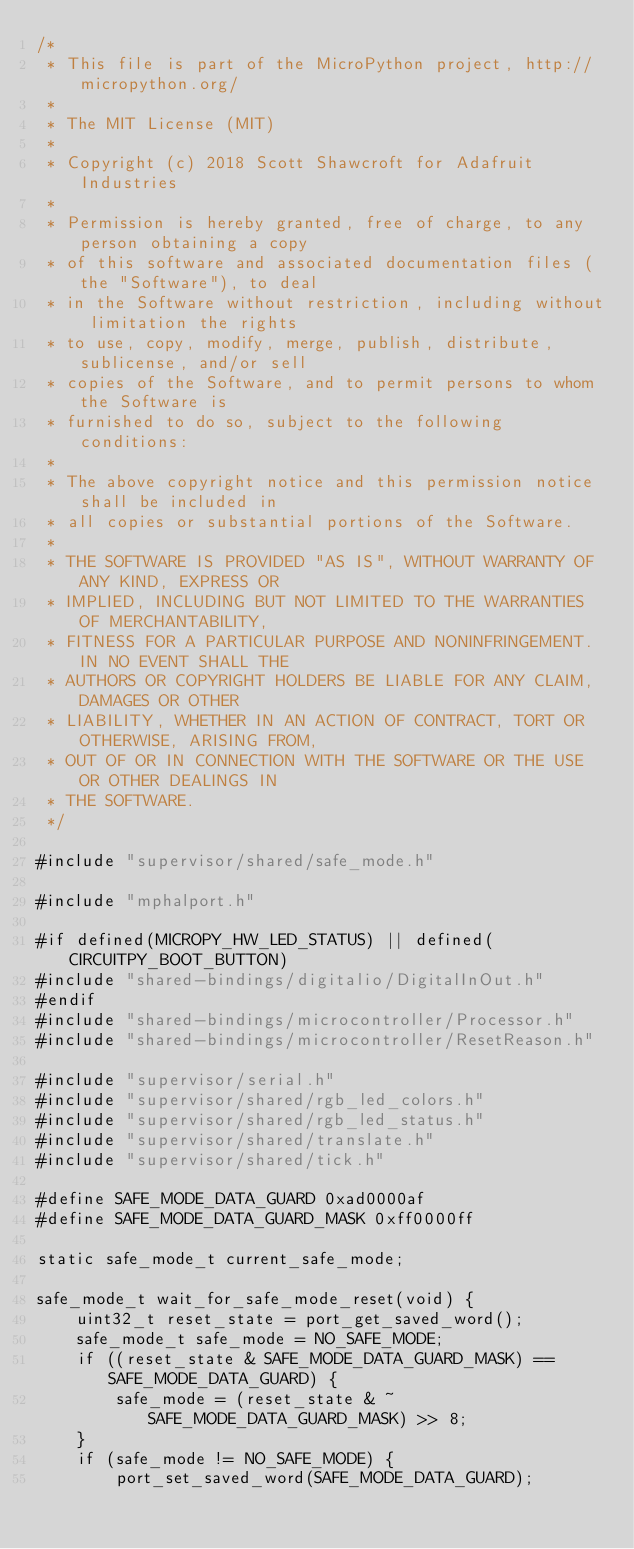<code> <loc_0><loc_0><loc_500><loc_500><_C_>/*
 * This file is part of the MicroPython project, http://micropython.org/
 *
 * The MIT License (MIT)
 *
 * Copyright (c) 2018 Scott Shawcroft for Adafruit Industries
 *
 * Permission is hereby granted, free of charge, to any person obtaining a copy
 * of this software and associated documentation files (the "Software"), to deal
 * in the Software without restriction, including without limitation the rights
 * to use, copy, modify, merge, publish, distribute, sublicense, and/or sell
 * copies of the Software, and to permit persons to whom the Software is
 * furnished to do so, subject to the following conditions:
 *
 * The above copyright notice and this permission notice shall be included in
 * all copies or substantial portions of the Software.
 *
 * THE SOFTWARE IS PROVIDED "AS IS", WITHOUT WARRANTY OF ANY KIND, EXPRESS OR
 * IMPLIED, INCLUDING BUT NOT LIMITED TO THE WARRANTIES OF MERCHANTABILITY,
 * FITNESS FOR A PARTICULAR PURPOSE AND NONINFRINGEMENT. IN NO EVENT SHALL THE
 * AUTHORS OR COPYRIGHT HOLDERS BE LIABLE FOR ANY CLAIM, DAMAGES OR OTHER
 * LIABILITY, WHETHER IN AN ACTION OF CONTRACT, TORT OR OTHERWISE, ARISING FROM,
 * OUT OF OR IN CONNECTION WITH THE SOFTWARE OR THE USE OR OTHER DEALINGS IN
 * THE SOFTWARE.
 */

#include "supervisor/shared/safe_mode.h"

#include "mphalport.h"

#if defined(MICROPY_HW_LED_STATUS) || defined(CIRCUITPY_BOOT_BUTTON)
#include "shared-bindings/digitalio/DigitalInOut.h"
#endif
#include "shared-bindings/microcontroller/Processor.h"
#include "shared-bindings/microcontroller/ResetReason.h"

#include "supervisor/serial.h"
#include "supervisor/shared/rgb_led_colors.h"
#include "supervisor/shared/rgb_led_status.h"
#include "supervisor/shared/translate.h"
#include "supervisor/shared/tick.h"

#define SAFE_MODE_DATA_GUARD 0xad0000af
#define SAFE_MODE_DATA_GUARD_MASK 0xff0000ff

static safe_mode_t current_safe_mode;

safe_mode_t wait_for_safe_mode_reset(void) {
    uint32_t reset_state = port_get_saved_word();
    safe_mode_t safe_mode = NO_SAFE_MODE;
    if ((reset_state & SAFE_MODE_DATA_GUARD_MASK) == SAFE_MODE_DATA_GUARD) {
        safe_mode = (reset_state & ~SAFE_MODE_DATA_GUARD_MASK) >> 8;
    }
    if (safe_mode != NO_SAFE_MODE) {
        port_set_saved_word(SAFE_MODE_DATA_GUARD);</code> 